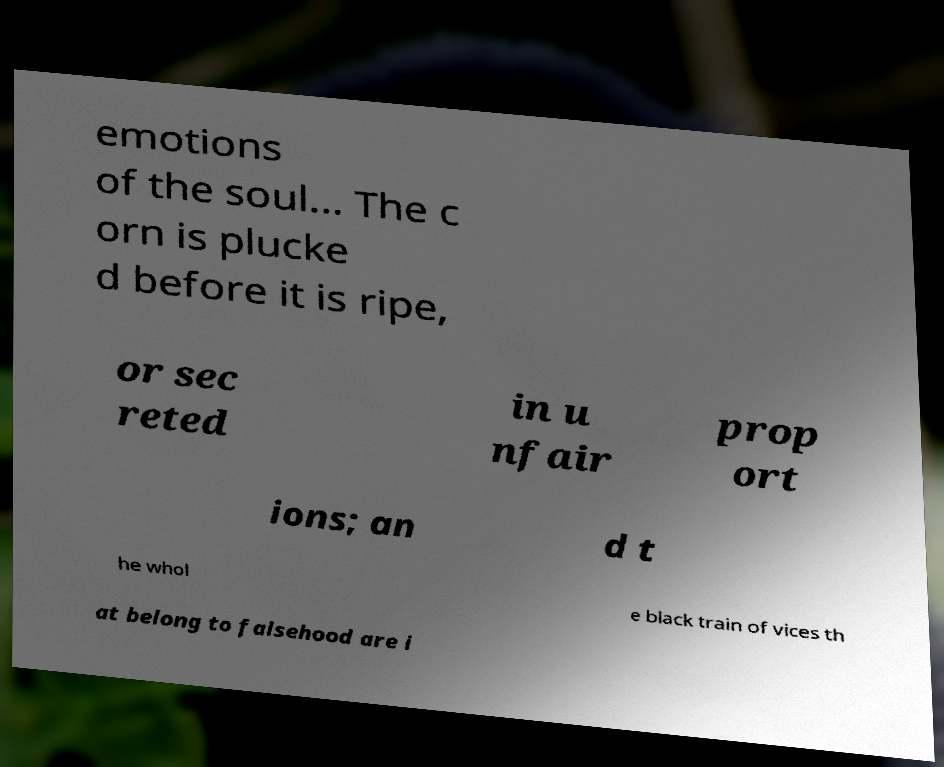Please identify and transcribe the text found in this image. emotions of the soul... The c orn is plucke d before it is ripe, or sec reted in u nfair prop ort ions; an d t he whol e black train of vices th at belong to falsehood are i 